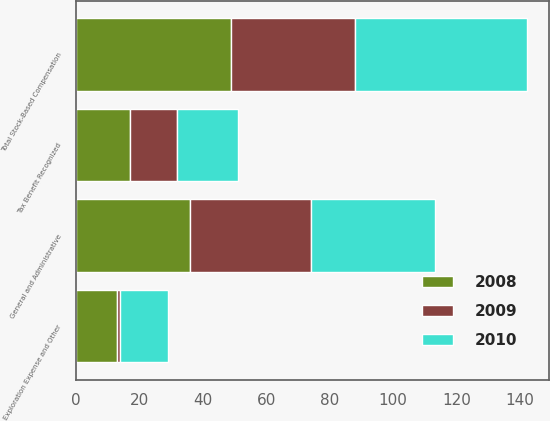<chart> <loc_0><loc_0><loc_500><loc_500><stacked_bar_chart><ecel><fcel>General and Administrative<fcel>Exploration Expense and Other<fcel>Total Stock-Based Compensation<fcel>Tax Benefit Recognized<nl><fcel>2010<fcel>39<fcel>15<fcel>54<fcel>19<nl><fcel>2008<fcel>36<fcel>13<fcel>49<fcel>17<nl><fcel>2009<fcel>38<fcel>1<fcel>39<fcel>15<nl></chart> 